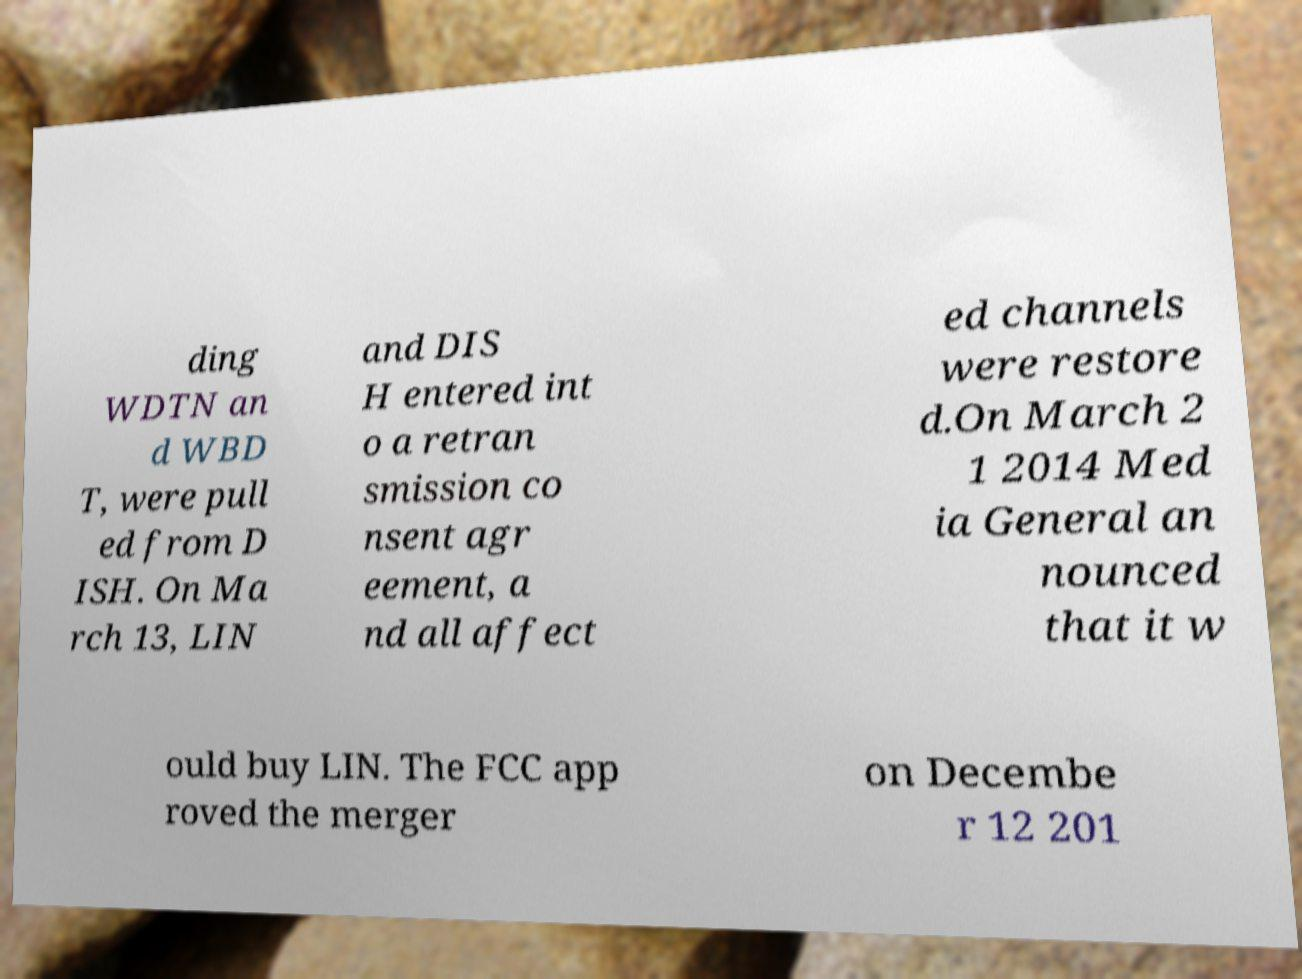Could you assist in decoding the text presented in this image and type it out clearly? ding WDTN an d WBD T, were pull ed from D ISH. On Ma rch 13, LIN and DIS H entered int o a retran smission co nsent agr eement, a nd all affect ed channels were restore d.On March 2 1 2014 Med ia General an nounced that it w ould buy LIN. The FCC app roved the merger on Decembe r 12 201 